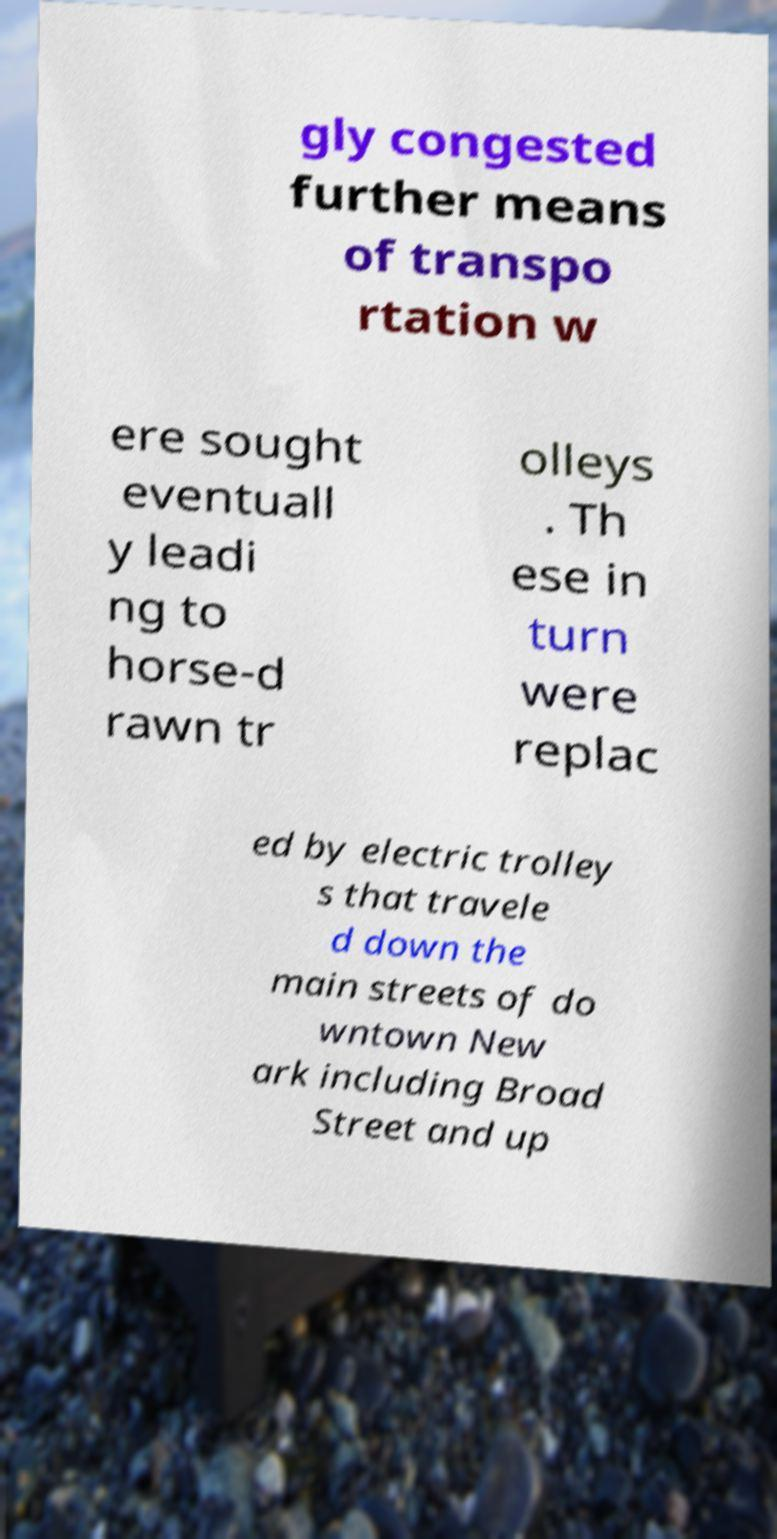Can you read and provide the text displayed in the image?This photo seems to have some interesting text. Can you extract and type it out for me? gly congested further means of transpo rtation w ere sought eventuall y leadi ng to horse-d rawn tr olleys . Th ese in turn were replac ed by electric trolley s that travele d down the main streets of do wntown New ark including Broad Street and up 